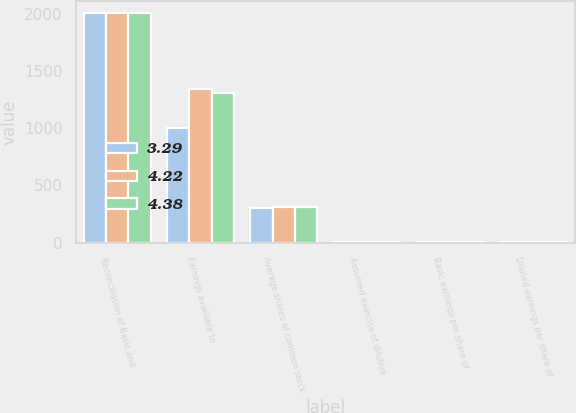Convert chart. <chart><loc_0><loc_0><loc_500><loc_500><stacked_bar_chart><ecel><fcel>Reconciliation of Basic and<fcel>Earnings available to<fcel>Average shares of common stock<fcel>Assumed exercise of dilutive<fcel>Basic earnings per share of<fcel>Diluted earnings per share of<nl><fcel>3.29<fcel>2009<fcel>1006<fcel>306<fcel>2<fcel>3.31<fcel>3.29<nl><fcel>4.22<fcel>2008<fcel>1342<fcel>307<fcel>3<fcel>4.41<fcel>4.38<nl><fcel>4.38<fcel>2007<fcel>1309<fcel>310<fcel>4<fcel>4.27<fcel>4.22<nl></chart> 